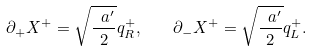<formula> <loc_0><loc_0><loc_500><loc_500>\partial _ { + } X ^ { + } = \sqrt { \frac { \ a ^ { \prime } } { 2 } } q ^ { + } _ { R } , \quad \partial _ { - } X ^ { + } = \sqrt { \frac { \ a ^ { \prime } } { 2 } } q ^ { + } _ { L } .</formula> 